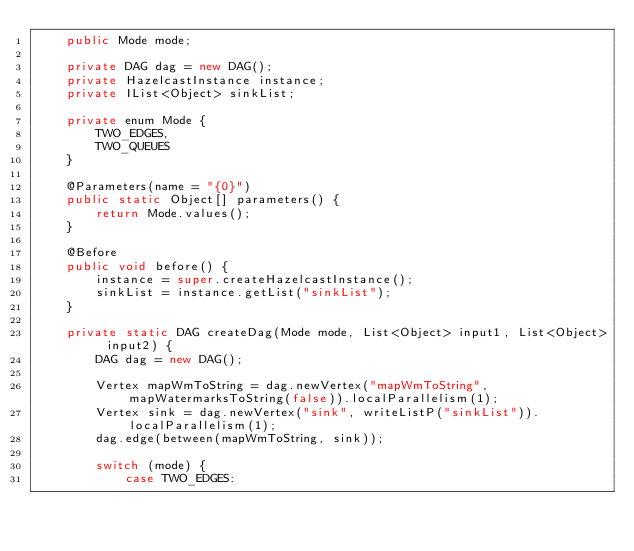Convert code to text. <code><loc_0><loc_0><loc_500><loc_500><_Java_>    public Mode mode;

    private DAG dag = new DAG();
    private HazelcastInstance instance;
    private IList<Object> sinkList;

    private enum Mode {
        TWO_EDGES,
        TWO_QUEUES
    }

    @Parameters(name = "{0}")
    public static Object[] parameters() {
        return Mode.values();
    }

    @Before
    public void before() {
        instance = super.createHazelcastInstance();
        sinkList = instance.getList("sinkList");
    }

    private static DAG createDag(Mode mode, List<Object> input1, List<Object> input2) {
        DAG dag = new DAG();

        Vertex mapWmToString = dag.newVertex("mapWmToString", mapWatermarksToString(false)).localParallelism(1);
        Vertex sink = dag.newVertex("sink", writeListP("sinkList")).localParallelism(1);
        dag.edge(between(mapWmToString, sink));

        switch (mode) {
            case TWO_EDGES:</code> 